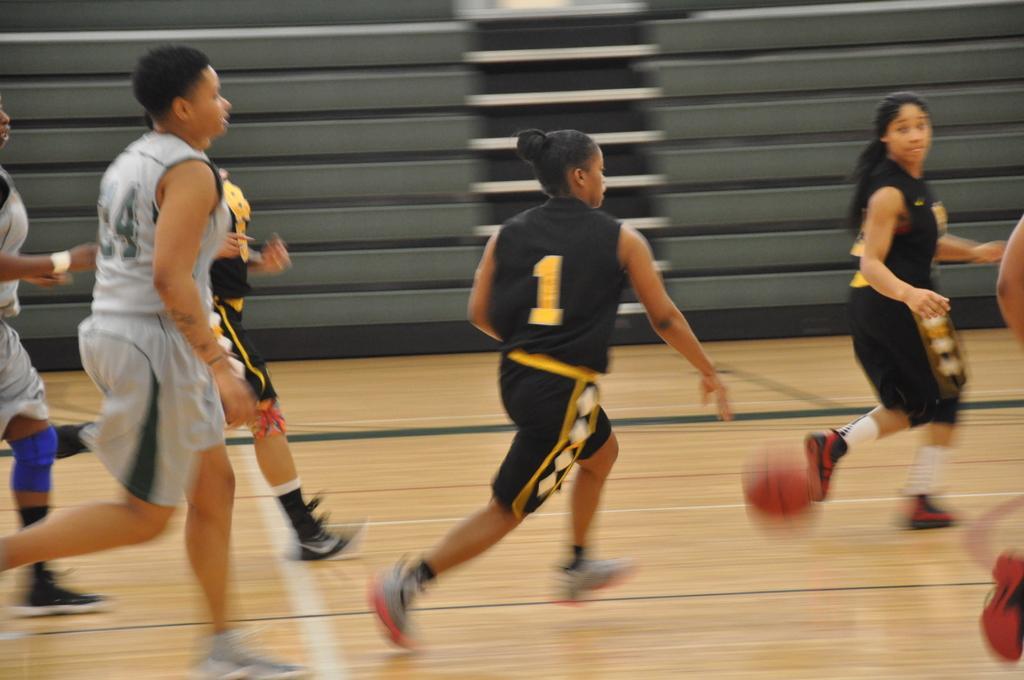Describe this image in one or two sentences. In this image I can see few people wearing t-shirts, shorts and running towards the right side. It seems like they are playing football. In the background there are some stairs. 